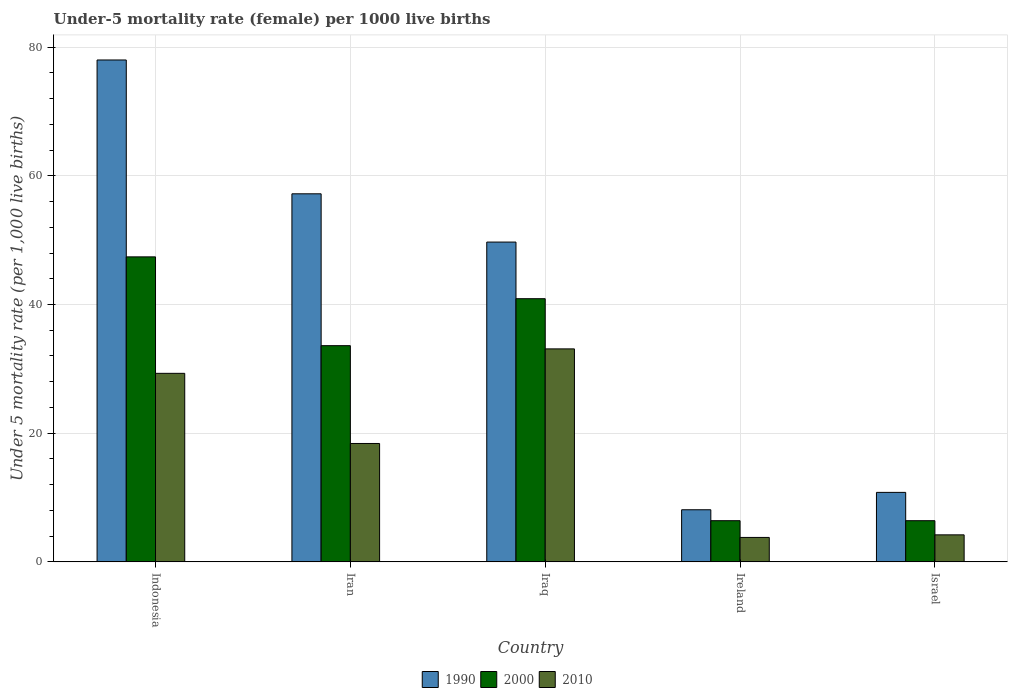How many different coloured bars are there?
Provide a short and direct response. 3. Are the number of bars per tick equal to the number of legend labels?
Offer a terse response. Yes. How many bars are there on the 2nd tick from the left?
Give a very brief answer. 3. How many bars are there on the 3rd tick from the right?
Give a very brief answer. 3. What is the label of the 4th group of bars from the left?
Make the answer very short. Ireland. What is the under-five mortality rate in 2000 in Iraq?
Keep it short and to the point. 40.9. Across all countries, what is the maximum under-five mortality rate in 2000?
Keep it short and to the point. 47.4. In which country was the under-five mortality rate in 1990 minimum?
Keep it short and to the point. Ireland. What is the total under-five mortality rate in 2010 in the graph?
Offer a very short reply. 88.8. What is the difference between the under-five mortality rate in 1990 in Ireland and the under-five mortality rate in 2010 in Israel?
Ensure brevity in your answer.  3.9. What is the average under-five mortality rate in 1990 per country?
Your answer should be very brief. 40.76. What is the difference between the under-five mortality rate of/in 2010 and under-five mortality rate of/in 1990 in Israel?
Ensure brevity in your answer.  -6.6. In how many countries, is the under-five mortality rate in 2010 greater than 28?
Provide a short and direct response. 2. What is the ratio of the under-five mortality rate in 2000 in Iraq to that in Israel?
Offer a terse response. 6.39. Is the under-five mortality rate in 2010 in Indonesia less than that in Iraq?
Give a very brief answer. Yes. Is the difference between the under-five mortality rate in 2010 in Iraq and Ireland greater than the difference between the under-five mortality rate in 1990 in Iraq and Ireland?
Your answer should be very brief. No. What is the difference between the highest and the second highest under-five mortality rate in 2010?
Your response must be concise. 14.7. What is the difference between the highest and the lowest under-five mortality rate in 2010?
Make the answer very short. 29.3. In how many countries, is the under-five mortality rate in 2000 greater than the average under-five mortality rate in 2000 taken over all countries?
Keep it short and to the point. 3. What does the 3rd bar from the right in Israel represents?
Offer a very short reply. 1990. Is it the case that in every country, the sum of the under-five mortality rate in 2010 and under-five mortality rate in 2000 is greater than the under-five mortality rate in 1990?
Provide a short and direct response. No. Are all the bars in the graph horizontal?
Provide a short and direct response. No. How many countries are there in the graph?
Offer a very short reply. 5. What is the difference between two consecutive major ticks on the Y-axis?
Keep it short and to the point. 20. Does the graph contain any zero values?
Keep it short and to the point. No. What is the title of the graph?
Your response must be concise. Under-5 mortality rate (female) per 1000 live births. Does "1970" appear as one of the legend labels in the graph?
Your response must be concise. No. What is the label or title of the X-axis?
Your response must be concise. Country. What is the label or title of the Y-axis?
Ensure brevity in your answer.  Under 5 mortality rate (per 1,0 live births). What is the Under 5 mortality rate (per 1,000 live births) in 1990 in Indonesia?
Ensure brevity in your answer.  78. What is the Under 5 mortality rate (per 1,000 live births) of 2000 in Indonesia?
Provide a short and direct response. 47.4. What is the Under 5 mortality rate (per 1,000 live births) of 2010 in Indonesia?
Make the answer very short. 29.3. What is the Under 5 mortality rate (per 1,000 live births) in 1990 in Iran?
Your response must be concise. 57.2. What is the Under 5 mortality rate (per 1,000 live births) of 2000 in Iran?
Provide a succinct answer. 33.6. What is the Under 5 mortality rate (per 1,000 live births) of 1990 in Iraq?
Offer a very short reply. 49.7. What is the Under 5 mortality rate (per 1,000 live births) of 2000 in Iraq?
Give a very brief answer. 40.9. What is the Under 5 mortality rate (per 1,000 live births) in 2010 in Iraq?
Keep it short and to the point. 33.1. What is the Under 5 mortality rate (per 1,000 live births) in 1990 in Ireland?
Offer a terse response. 8.1. What is the Under 5 mortality rate (per 1,000 live births) in 2000 in Ireland?
Your answer should be compact. 6.4. What is the Under 5 mortality rate (per 1,000 live births) in 1990 in Israel?
Keep it short and to the point. 10.8. Across all countries, what is the maximum Under 5 mortality rate (per 1,000 live births) of 2000?
Keep it short and to the point. 47.4. Across all countries, what is the maximum Under 5 mortality rate (per 1,000 live births) in 2010?
Give a very brief answer. 33.1. Across all countries, what is the minimum Under 5 mortality rate (per 1,000 live births) of 2000?
Offer a very short reply. 6.4. Across all countries, what is the minimum Under 5 mortality rate (per 1,000 live births) in 2010?
Provide a succinct answer. 3.8. What is the total Under 5 mortality rate (per 1,000 live births) of 1990 in the graph?
Give a very brief answer. 203.8. What is the total Under 5 mortality rate (per 1,000 live births) in 2000 in the graph?
Provide a short and direct response. 134.7. What is the total Under 5 mortality rate (per 1,000 live births) in 2010 in the graph?
Your answer should be very brief. 88.8. What is the difference between the Under 5 mortality rate (per 1,000 live births) in 1990 in Indonesia and that in Iran?
Offer a very short reply. 20.8. What is the difference between the Under 5 mortality rate (per 1,000 live births) of 2000 in Indonesia and that in Iran?
Offer a terse response. 13.8. What is the difference between the Under 5 mortality rate (per 1,000 live births) in 1990 in Indonesia and that in Iraq?
Your response must be concise. 28.3. What is the difference between the Under 5 mortality rate (per 1,000 live births) of 2010 in Indonesia and that in Iraq?
Offer a very short reply. -3.8. What is the difference between the Under 5 mortality rate (per 1,000 live births) of 1990 in Indonesia and that in Ireland?
Keep it short and to the point. 69.9. What is the difference between the Under 5 mortality rate (per 1,000 live births) in 2000 in Indonesia and that in Ireland?
Provide a short and direct response. 41. What is the difference between the Under 5 mortality rate (per 1,000 live births) of 1990 in Indonesia and that in Israel?
Make the answer very short. 67.2. What is the difference between the Under 5 mortality rate (per 1,000 live births) in 2010 in Indonesia and that in Israel?
Offer a very short reply. 25.1. What is the difference between the Under 5 mortality rate (per 1,000 live births) in 2000 in Iran and that in Iraq?
Your answer should be compact. -7.3. What is the difference between the Under 5 mortality rate (per 1,000 live births) of 2010 in Iran and that in Iraq?
Keep it short and to the point. -14.7. What is the difference between the Under 5 mortality rate (per 1,000 live births) of 1990 in Iran and that in Ireland?
Offer a terse response. 49.1. What is the difference between the Under 5 mortality rate (per 1,000 live births) in 2000 in Iran and that in Ireland?
Ensure brevity in your answer.  27.2. What is the difference between the Under 5 mortality rate (per 1,000 live births) in 2010 in Iran and that in Ireland?
Provide a succinct answer. 14.6. What is the difference between the Under 5 mortality rate (per 1,000 live births) of 1990 in Iran and that in Israel?
Your answer should be very brief. 46.4. What is the difference between the Under 5 mortality rate (per 1,000 live births) of 2000 in Iran and that in Israel?
Your answer should be very brief. 27.2. What is the difference between the Under 5 mortality rate (per 1,000 live births) of 1990 in Iraq and that in Ireland?
Offer a terse response. 41.6. What is the difference between the Under 5 mortality rate (per 1,000 live births) of 2000 in Iraq and that in Ireland?
Keep it short and to the point. 34.5. What is the difference between the Under 5 mortality rate (per 1,000 live births) of 2010 in Iraq and that in Ireland?
Offer a terse response. 29.3. What is the difference between the Under 5 mortality rate (per 1,000 live births) in 1990 in Iraq and that in Israel?
Provide a short and direct response. 38.9. What is the difference between the Under 5 mortality rate (per 1,000 live births) in 2000 in Iraq and that in Israel?
Offer a terse response. 34.5. What is the difference between the Under 5 mortality rate (per 1,000 live births) in 2010 in Iraq and that in Israel?
Your response must be concise. 28.9. What is the difference between the Under 5 mortality rate (per 1,000 live births) in 1990 in Ireland and that in Israel?
Ensure brevity in your answer.  -2.7. What is the difference between the Under 5 mortality rate (per 1,000 live births) of 1990 in Indonesia and the Under 5 mortality rate (per 1,000 live births) of 2000 in Iran?
Your answer should be compact. 44.4. What is the difference between the Under 5 mortality rate (per 1,000 live births) in 1990 in Indonesia and the Under 5 mortality rate (per 1,000 live births) in 2010 in Iran?
Your response must be concise. 59.6. What is the difference between the Under 5 mortality rate (per 1,000 live births) in 1990 in Indonesia and the Under 5 mortality rate (per 1,000 live births) in 2000 in Iraq?
Offer a terse response. 37.1. What is the difference between the Under 5 mortality rate (per 1,000 live births) in 1990 in Indonesia and the Under 5 mortality rate (per 1,000 live births) in 2010 in Iraq?
Offer a very short reply. 44.9. What is the difference between the Under 5 mortality rate (per 1,000 live births) of 2000 in Indonesia and the Under 5 mortality rate (per 1,000 live births) of 2010 in Iraq?
Offer a very short reply. 14.3. What is the difference between the Under 5 mortality rate (per 1,000 live births) of 1990 in Indonesia and the Under 5 mortality rate (per 1,000 live births) of 2000 in Ireland?
Give a very brief answer. 71.6. What is the difference between the Under 5 mortality rate (per 1,000 live births) in 1990 in Indonesia and the Under 5 mortality rate (per 1,000 live births) in 2010 in Ireland?
Provide a succinct answer. 74.2. What is the difference between the Under 5 mortality rate (per 1,000 live births) in 2000 in Indonesia and the Under 5 mortality rate (per 1,000 live births) in 2010 in Ireland?
Keep it short and to the point. 43.6. What is the difference between the Under 5 mortality rate (per 1,000 live births) in 1990 in Indonesia and the Under 5 mortality rate (per 1,000 live births) in 2000 in Israel?
Provide a short and direct response. 71.6. What is the difference between the Under 5 mortality rate (per 1,000 live births) in 1990 in Indonesia and the Under 5 mortality rate (per 1,000 live births) in 2010 in Israel?
Ensure brevity in your answer.  73.8. What is the difference between the Under 5 mortality rate (per 1,000 live births) in 2000 in Indonesia and the Under 5 mortality rate (per 1,000 live births) in 2010 in Israel?
Your response must be concise. 43.2. What is the difference between the Under 5 mortality rate (per 1,000 live births) of 1990 in Iran and the Under 5 mortality rate (per 1,000 live births) of 2000 in Iraq?
Make the answer very short. 16.3. What is the difference between the Under 5 mortality rate (per 1,000 live births) of 1990 in Iran and the Under 5 mortality rate (per 1,000 live births) of 2010 in Iraq?
Provide a short and direct response. 24.1. What is the difference between the Under 5 mortality rate (per 1,000 live births) in 1990 in Iran and the Under 5 mortality rate (per 1,000 live births) in 2000 in Ireland?
Provide a succinct answer. 50.8. What is the difference between the Under 5 mortality rate (per 1,000 live births) of 1990 in Iran and the Under 5 mortality rate (per 1,000 live births) of 2010 in Ireland?
Your answer should be compact. 53.4. What is the difference between the Under 5 mortality rate (per 1,000 live births) in 2000 in Iran and the Under 5 mortality rate (per 1,000 live births) in 2010 in Ireland?
Your answer should be compact. 29.8. What is the difference between the Under 5 mortality rate (per 1,000 live births) in 1990 in Iran and the Under 5 mortality rate (per 1,000 live births) in 2000 in Israel?
Offer a terse response. 50.8. What is the difference between the Under 5 mortality rate (per 1,000 live births) of 2000 in Iran and the Under 5 mortality rate (per 1,000 live births) of 2010 in Israel?
Give a very brief answer. 29.4. What is the difference between the Under 5 mortality rate (per 1,000 live births) of 1990 in Iraq and the Under 5 mortality rate (per 1,000 live births) of 2000 in Ireland?
Make the answer very short. 43.3. What is the difference between the Under 5 mortality rate (per 1,000 live births) of 1990 in Iraq and the Under 5 mortality rate (per 1,000 live births) of 2010 in Ireland?
Make the answer very short. 45.9. What is the difference between the Under 5 mortality rate (per 1,000 live births) in 2000 in Iraq and the Under 5 mortality rate (per 1,000 live births) in 2010 in Ireland?
Your answer should be compact. 37.1. What is the difference between the Under 5 mortality rate (per 1,000 live births) of 1990 in Iraq and the Under 5 mortality rate (per 1,000 live births) of 2000 in Israel?
Make the answer very short. 43.3. What is the difference between the Under 5 mortality rate (per 1,000 live births) in 1990 in Iraq and the Under 5 mortality rate (per 1,000 live births) in 2010 in Israel?
Provide a short and direct response. 45.5. What is the difference between the Under 5 mortality rate (per 1,000 live births) in 2000 in Iraq and the Under 5 mortality rate (per 1,000 live births) in 2010 in Israel?
Your answer should be compact. 36.7. What is the difference between the Under 5 mortality rate (per 1,000 live births) of 1990 in Ireland and the Under 5 mortality rate (per 1,000 live births) of 2010 in Israel?
Provide a short and direct response. 3.9. What is the difference between the Under 5 mortality rate (per 1,000 live births) of 2000 in Ireland and the Under 5 mortality rate (per 1,000 live births) of 2010 in Israel?
Your response must be concise. 2.2. What is the average Under 5 mortality rate (per 1,000 live births) of 1990 per country?
Offer a terse response. 40.76. What is the average Under 5 mortality rate (per 1,000 live births) of 2000 per country?
Keep it short and to the point. 26.94. What is the average Under 5 mortality rate (per 1,000 live births) of 2010 per country?
Your response must be concise. 17.76. What is the difference between the Under 5 mortality rate (per 1,000 live births) in 1990 and Under 5 mortality rate (per 1,000 live births) in 2000 in Indonesia?
Keep it short and to the point. 30.6. What is the difference between the Under 5 mortality rate (per 1,000 live births) in 1990 and Under 5 mortality rate (per 1,000 live births) in 2010 in Indonesia?
Ensure brevity in your answer.  48.7. What is the difference between the Under 5 mortality rate (per 1,000 live births) of 1990 and Under 5 mortality rate (per 1,000 live births) of 2000 in Iran?
Your answer should be very brief. 23.6. What is the difference between the Under 5 mortality rate (per 1,000 live births) in 1990 and Under 5 mortality rate (per 1,000 live births) in 2010 in Iran?
Keep it short and to the point. 38.8. What is the difference between the Under 5 mortality rate (per 1,000 live births) of 2000 and Under 5 mortality rate (per 1,000 live births) of 2010 in Iran?
Your response must be concise. 15.2. What is the difference between the Under 5 mortality rate (per 1,000 live births) in 1990 and Under 5 mortality rate (per 1,000 live births) in 2000 in Iraq?
Provide a short and direct response. 8.8. What is the difference between the Under 5 mortality rate (per 1,000 live births) of 1990 and Under 5 mortality rate (per 1,000 live births) of 2010 in Iraq?
Your answer should be very brief. 16.6. What is the difference between the Under 5 mortality rate (per 1,000 live births) of 1990 and Under 5 mortality rate (per 1,000 live births) of 2000 in Ireland?
Provide a succinct answer. 1.7. What is the difference between the Under 5 mortality rate (per 1,000 live births) in 1990 and Under 5 mortality rate (per 1,000 live births) in 2010 in Ireland?
Offer a terse response. 4.3. What is the difference between the Under 5 mortality rate (per 1,000 live births) of 2000 and Under 5 mortality rate (per 1,000 live births) of 2010 in Israel?
Your response must be concise. 2.2. What is the ratio of the Under 5 mortality rate (per 1,000 live births) of 1990 in Indonesia to that in Iran?
Make the answer very short. 1.36. What is the ratio of the Under 5 mortality rate (per 1,000 live births) of 2000 in Indonesia to that in Iran?
Offer a very short reply. 1.41. What is the ratio of the Under 5 mortality rate (per 1,000 live births) in 2010 in Indonesia to that in Iran?
Your answer should be very brief. 1.59. What is the ratio of the Under 5 mortality rate (per 1,000 live births) in 1990 in Indonesia to that in Iraq?
Offer a very short reply. 1.57. What is the ratio of the Under 5 mortality rate (per 1,000 live births) of 2000 in Indonesia to that in Iraq?
Your response must be concise. 1.16. What is the ratio of the Under 5 mortality rate (per 1,000 live births) in 2010 in Indonesia to that in Iraq?
Keep it short and to the point. 0.89. What is the ratio of the Under 5 mortality rate (per 1,000 live births) in 1990 in Indonesia to that in Ireland?
Give a very brief answer. 9.63. What is the ratio of the Under 5 mortality rate (per 1,000 live births) in 2000 in Indonesia to that in Ireland?
Give a very brief answer. 7.41. What is the ratio of the Under 5 mortality rate (per 1,000 live births) in 2010 in Indonesia to that in Ireland?
Your response must be concise. 7.71. What is the ratio of the Under 5 mortality rate (per 1,000 live births) of 1990 in Indonesia to that in Israel?
Offer a very short reply. 7.22. What is the ratio of the Under 5 mortality rate (per 1,000 live births) in 2000 in Indonesia to that in Israel?
Offer a very short reply. 7.41. What is the ratio of the Under 5 mortality rate (per 1,000 live births) of 2010 in Indonesia to that in Israel?
Give a very brief answer. 6.98. What is the ratio of the Under 5 mortality rate (per 1,000 live births) in 1990 in Iran to that in Iraq?
Your answer should be compact. 1.15. What is the ratio of the Under 5 mortality rate (per 1,000 live births) of 2000 in Iran to that in Iraq?
Ensure brevity in your answer.  0.82. What is the ratio of the Under 5 mortality rate (per 1,000 live births) in 2010 in Iran to that in Iraq?
Your answer should be compact. 0.56. What is the ratio of the Under 5 mortality rate (per 1,000 live births) of 1990 in Iran to that in Ireland?
Your answer should be very brief. 7.06. What is the ratio of the Under 5 mortality rate (per 1,000 live births) in 2000 in Iran to that in Ireland?
Provide a succinct answer. 5.25. What is the ratio of the Under 5 mortality rate (per 1,000 live births) of 2010 in Iran to that in Ireland?
Provide a short and direct response. 4.84. What is the ratio of the Under 5 mortality rate (per 1,000 live births) in 1990 in Iran to that in Israel?
Your answer should be compact. 5.3. What is the ratio of the Under 5 mortality rate (per 1,000 live births) of 2000 in Iran to that in Israel?
Give a very brief answer. 5.25. What is the ratio of the Under 5 mortality rate (per 1,000 live births) of 2010 in Iran to that in Israel?
Your response must be concise. 4.38. What is the ratio of the Under 5 mortality rate (per 1,000 live births) in 1990 in Iraq to that in Ireland?
Your answer should be very brief. 6.14. What is the ratio of the Under 5 mortality rate (per 1,000 live births) in 2000 in Iraq to that in Ireland?
Give a very brief answer. 6.39. What is the ratio of the Under 5 mortality rate (per 1,000 live births) in 2010 in Iraq to that in Ireland?
Provide a short and direct response. 8.71. What is the ratio of the Under 5 mortality rate (per 1,000 live births) of 1990 in Iraq to that in Israel?
Offer a terse response. 4.6. What is the ratio of the Under 5 mortality rate (per 1,000 live births) in 2000 in Iraq to that in Israel?
Give a very brief answer. 6.39. What is the ratio of the Under 5 mortality rate (per 1,000 live births) of 2010 in Iraq to that in Israel?
Make the answer very short. 7.88. What is the ratio of the Under 5 mortality rate (per 1,000 live births) of 2000 in Ireland to that in Israel?
Your response must be concise. 1. What is the ratio of the Under 5 mortality rate (per 1,000 live births) in 2010 in Ireland to that in Israel?
Ensure brevity in your answer.  0.9. What is the difference between the highest and the second highest Under 5 mortality rate (per 1,000 live births) in 1990?
Provide a short and direct response. 20.8. What is the difference between the highest and the second highest Under 5 mortality rate (per 1,000 live births) of 2000?
Provide a succinct answer. 6.5. What is the difference between the highest and the lowest Under 5 mortality rate (per 1,000 live births) in 1990?
Offer a terse response. 69.9. What is the difference between the highest and the lowest Under 5 mortality rate (per 1,000 live births) of 2010?
Your answer should be very brief. 29.3. 